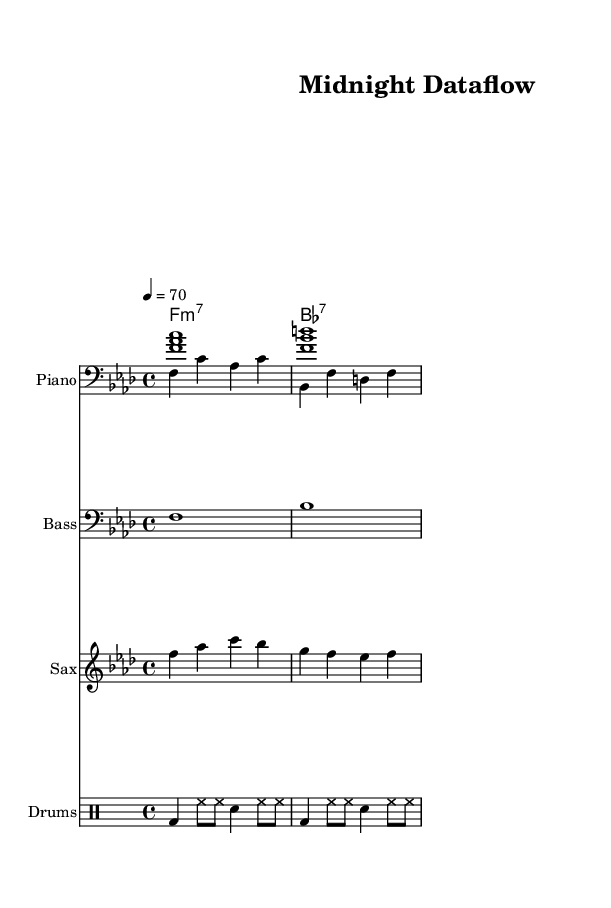What is the key signature of this music? The key signature is indicated by the number of sharps or flats present at the beginning of the staff. In this piece, there are four flats, which corresponds to the key of F minor.
Answer: F minor What is the time signature of this music? The time signature is shown at the beginning of the music and indicates how many beats are in each measure. Here, it is marked as 4/4, meaning there are four beats per measure.
Answer: 4/4 What is the tempo marking of this music? Tempo marking indicates the speed of the piece and is typically noted with a number representing beats per minute and a term indicating the mood. In this case, it states 4 = 70, meaning the quarter note gets 70 beats per minute.
Answer: 70 How many measures are there in the melody? To determine the number of measures, we count the bar lines separating the musical phrases. The melody section has four measures present before concluding.
Answer: 4 What instrument plays the saxophone part? The instrument name is typically shown at the start of its staff. In this score, the instrument labeled "Sax" clearly indicates the saxophone plays this part.
Answer: Saxophone Which chord is not present in the chord names? The chord names provide a list of chords played throughout the piece. Given the chords are F minor 7 and B flat 7, we analyze what is not listed. The absence of a C minor chord confirms it is not present in the piece.
Answer: C minor Is the piano part played with both hands? The score includes two separate staves for the piano, showing a right hand and left hand part, which indicates that both hands of the pianist are utilized in this composition.
Answer: Yes 